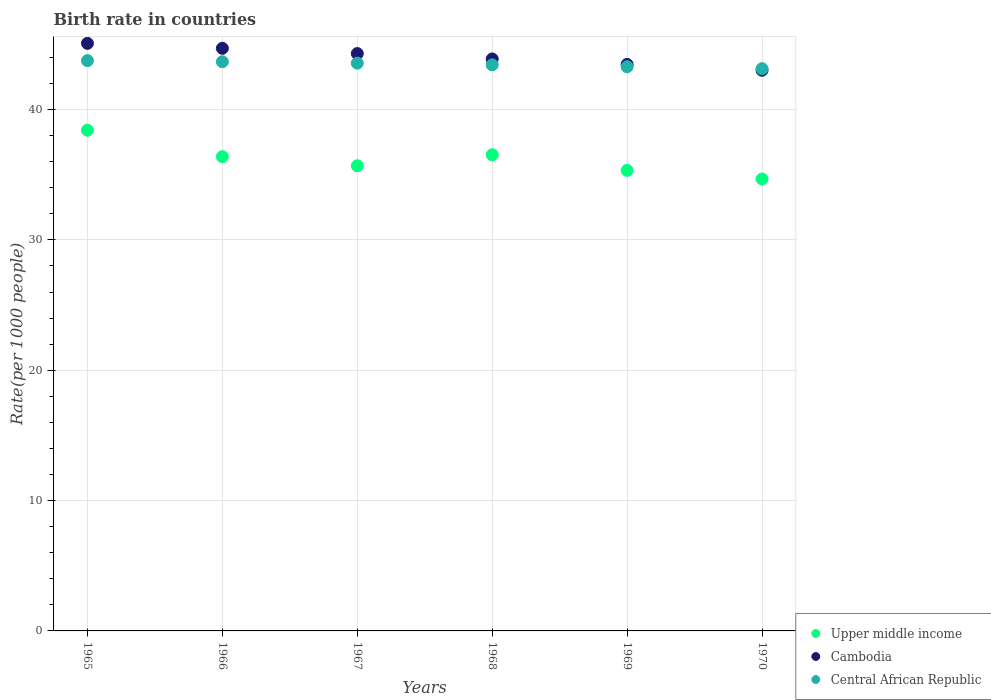What is the birth rate in Cambodia in 1965?
Give a very brief answer. 45.08. Across all years, what is the maximum birth rate in Cambodia?
Offer a very short reply. 45.08. Across all years, what is the minimum birth rate in Upper middle income?
Your answer should be compact. 34.67. In which year was the birth rate in Cambodia maximum?
Offer a very short reply. 1965. What is the total birth rate in Central African Republic in the graph?
Your answer should be compact. 260.83. What is the difference between the birth rate in Upper middle income in 1965 and that in 1970?
Your response must be concise. 3.74. What is the difference between the birth rate in Cambodia in 1970 and the birth rate in Upper middle income in 1968?
Your answer should be very brief. 6.48. What is the average birth rate in Upper middle income per year?
Provide a short and direct response. 36.17. In the year 1967, what is the difference between the birth rate in Cambodia and birth rate in Upper middle income?
Keep it short and to the point. 8.61. In how many years, is the birth rate in Upper middle income greater than 4?
Make the answer very short. 6. What is the ratio of the birth rate in Central African Republic in 1965 to that in 1967?
Give a very brief answer. 1. Is the birth rate in Upper middle income in 1966 less than that in 1969?
Your response must be concise. No. What is the difference between the highest and the second highest birth rate in Upper middle income?
Keep it short and to the point. 1.88. What is the difference between the highest and the lowest birth rate in Central African Republic?
Your response must be concise. 0.62. In how many years, is the birth rate in Upper middle income greater than the average birth rate in Upper middle income taken over all years?
Make the answer very short. 3. Is the sum of the birth rate in Upper middle income in 1967 and 1968 greater than the maximum birth rate in Central African Republic across all years?
Offer a very short reply. Yes. Is the birth rate in Upper middle income strictly less than the birth rate in Central African Republic over the years?
Your answer should be very brief. Yes. How many dotlines are there?
Provide a short and direct response. 3. Where does the legend appear in the graph?
Ensure brevity in your answer.  Bottom right. How are the legend labels stacked?
Provide a short and direct response. Vertical. What is the title of the graph?
Provide a succinct answer. Birth rate in countries. Does "Mauritius" appear as one of the legend labels in the graph?
Make the answer very short. No. What is the label or title of the X-axis?
Your answer should be very brief. Years. What is the label or title of the Y-axis?
Ensure brevity in your answer.  Rate(per 1000 people). What is the Rate(per 1000 people) of Upper middle income in 1965?
Keep it short and to the point. 38.41. What is the Rate(per 1000 people) in Cambodia in 1965?
Your response must be concise. 45.08. What is the Rate(per 1000 people) of Central African Republic in 1965?
Give a very brief answer. 43.75. What is the Rate(per 1000 people) in Upper middle income in 1966?
Your answer should be very brief. 36.39. What is the Rate(per 1000 people) of Cambodia in 1966?
Offer a very short reply. 44.7. What is the Rate(per 1000 people) in Central African Republic in 1966?
Your response must be concise. 43.67. What is the Rate(per 1000 people) in Upper middle income in 1967?
Your answer should be compact. 35.69. What is the Rate(per 1000 people) of Cambodia in 1967?
Provide a succinct answer. 44.3. What is the Rate(per 1000 people) of Central African Republic in 1967?
Ensure brevity in your answer.  43.56. What is the Rate(per 1000 people) in Upper middle income in 1968?
Make the answer very short. 36.53. What is the Rate(per 1000 people) in Cambodia in 1968?
Your answer should be very brief. 43.88. What is the Rate(per 1000 people) of Central African Republic in 1968?
Make the answer very short. 43.43. What is the Rate(per 1000 people) in Upper middle income in 1969?
Your response must be concise. 35.33. What is the Rate(per 1000 people) in Cambodia in 1969?
Ensure brevity in your answer.  43.46. What is the Rate(per 1000 people) in Central African Republic in 1969?
Ensure brevity in your answer.  43.29. What is the Rate(per 1000 people) in Upper middle income in 1970?
Provide a succinct answer. 34.67. What is the Rate(per 1000 people) in Cambodia in 1970?
Offer a very short reply. 43.02. What is the Rate(per 1000 people) of Central African Republic in 1970?
Provide a short and direct response. 43.13. Across all years, what is the maximum Rate(per 1000 people) in Upper middle income?
Keep it short and to the point. 38.41. Across all years, what is the maximum Rate(per 1000 people) in Cambodia?
Give a very brief answer. 45.08. Across all years, what is the maximum Rate(per 1000 people) in Central African Republic?
Make the answer very short. 43.75. Across all years, what is the minimum Rate(per 1000 people) of Upper middle income?
Your response must be concise. 34.67. Across all years, what is the minimum Rate(per 1000 people) of Cambodia?
Ensure brevity in your answer.  43.02. Across all years, what is the minimum Rate(per 1000 people) of Central African Republic?
Make the answer very short. 43.13. What is the total Rate(per 1000 people) of Upper middle income in the graph?
Your answer should be compact. 217.02. What is the total Rate(per 1000 people) in Cambodia in the graph?
Provide a short and direct response. 264.43. What is the total Rate(per 1000 people) of Central African Republic in the graph?
Ensure brevity in your answer.  260.83. What is the difference between the Rate(per 1000 people) in Upper middle income in 1965 and that in 1966?
Ensure brevity in your answer.  2.03. What is the difference between the Rate(per 1000 people) in Cambodia in 1965 and that in 1966?
Provide a short and direct response. 0.38. What is the difference between the Rate(per 1000 people) in Central African Republic in 1965 and that in 1966?
Provide a short and direct response. 0.08. What is the difference between the Rate(per 1000 people) in Upper middle income in 1965 and that in 1967?
Your answer should be very brief. 2.73. What is the difference between the Rate(per 1000 people) of Cambodia in 1965 and that in 1967?
Offer a terse response. 0.78. What is the difference between the Rate(per 1000 people) of Central African Republic in 1965 and that in 1967?
Offer a very short reply. 0.19. What is the difference between the Rate(per 1000 people) in Upper middle income in 1965 and that in 1968?
Offer a terse response. 1.88. What is the difference between the Rate(per 1000 people) of Cambodia in 1965 and that in 1968?
Provide a short and direct response. 1.2. What is the difference between the Rate(per 1000 people) in Central African Republic in 1965 and that in 1968?
Offer a terse response. 0.32. What is the difference between the Rate(per 1000 people) in Upper middle income in 1965 and that in 1969?
Your answer should be compact. 3.08. What is the difference between the Rate(per 1000 people) of Cambodia in 1965 and that in 1969?
Provide a succinct answer. 1.61. What is the difference between the Rate(per 1000 people) in Central African Republic in 1965 and that in 1969?
Your answer should be compact. 0.47. What is the difference between the Rate(per 1000 people) of Upper middle income in 1965 and that in 1970?
Your answer should be very brief. 3.74. What is the difference between the Rate(per 1000 people) of Cambodia in 1965 and that in 1970?
Provide a short and direct response. 2.06. What is the difference between the Rate(per 1000 people) in Central African Republic in 1965 and that in 1970?
Your answer should be compact. 0.62. What is the difference between the Rate(per 1000 people) of Upper middle income in 1966 and that in 1967?
Make the answer very short. 0.7. What is the difference between the Rate(per 1000 people) in Cambodia in 1966 and that in 1967?
Offer a very short reply. 0.4. What is the difference between the Rate(per 1000 people) in Central African Republic in 1966 and that in 1967?
Offer a terse response. 0.11. What is the difference between the Rate(per 1000 people) of Upper middle income in 1966 and that in 1968?
Ensure brevity in your answer.  -0.14. What is the difference between the Rate(per 1000 people) of Cambodia in 1966 and that in 1968?
Make the answer very short. 0.82. What is the difference between the Rate(per 1000 people) of Central African Republic in 1966 and that in 1968?
Your response must be concise. 0.24. What is the difference between the Rate(per 1000 people) of Upper middle income in 1966 and that in 1969?
Make the answer very short. 1.05. What is the difference between the Rate(per 1000 people) of Cambodia in 1966 and that in 1969?
Your response must be concise. 1.23. What is the difference between the Rate(per 1000 people) of Central African Republic in 1966 and that in 1969?
Offer a very short reply. 0.38. What is the difference between the Rate(per 1000 people) of Upper middle income in 1966 and that in 1970?
Your answer should be compact. 1.71. What is the difference between the Rate(per 1000 people) in Cambodia in 1966 and that in 1970?
Ensure brevity in your answer.  1.68. What is the difference between the Rate(per 1000 people) of Central African Republic in 1966 and that in 1970?
Provide a short and direct response. 0.53. What is the difference between the Rate(per 1000 people) of Upper middle income in 1967 and that in 1968?
Your response must be concise. -0.84. What is the difference between the Rate(per 1000 people) of Cambodia in 1967 and that in 1968?
Your response must be concise. 0.41. What is the difference between the Rate(per 1000 people) in Central African Republic in 1967 and that in 1968?
Your response must be concise. 0.13. What is the difference between the Rate(per 1000 people) in Upper middle income in 1967 and that in 1969?
Ensure brevity in your answer.  0.36. What is the difference between the Rate(per 1000 people) in Cambodia in 1967 and that in 1969?
Give a very brief answer. 0.83. What is the difference between the Rate(per 1000 people) of Central African Republic in 1967 and that in 1969?
Keep it short and to the point. 0.27. What is the difference between the Rate(per 1000 people) of Upper middle income in 1967 and that in 1970?
Your answer should be compact. 1.02. What is the difference between the Rate(per 1000 people) of Cambodia in 1967 and that in 1970?
Make the answer very short. 1.28. What is the difference between the Rate(per 1000 people) in Central African Republic in 1967 and that in 1970?
Ensure brevity in your answer.  0.42. What is the difference between the Rate(per 1000 people) in Upper middle income in 1968 and that in 1969?
Offer a terse response. 1.2. What is the difference between the Rate(per 1000 people) in Cambodia in 1968 and that in 1969?
Ensure brevity in your answer.  0.42. What is the difference between the Rate(per 1000 people) of Central African Republic in 1968 and that in 1969?
Make the answer very short. 0.14. What is the difference between the Rate(per 1000 people) in Upper middle income in 1968 and that in 1970?
Offer a very short reply. 1.86. What is the difference between the Rate(per 1000 people) in Cambodia in 1968 and that in 1970?
Offer a very short reply. 0.87. What is the difference between the Rate(per 1000 people) of Central African Republic in 1968 and that in 1970?
Offer a terse response. 0.29. What is the difference between the Rate(per 1000 people) of Upper middle income in 1969 and that in 1970?
Your answer should be very brief. 0.66. What is the difference between the Rate(per 1000 people) of Cambodia in 1969 and that in 1970?
Make the answer very short. 0.45. What is the difference between the Rate(per 1000 people) of Central African Republic in 1969 and that in 1970?
Give a very brief answer. 0.15. What is the difference between the Rate(per 1000 people) in Upper middle income in 1965 and the Rate(per 1000 people) in Cambodia in 1966?
Your answer should be very brief. -6.28. What is the difference between the Rate(per 1000 people) in Upper middle income in 1965 and the Rate(per 1000 people) in Central African Republic in 1966?
Your response must be concise. -5.25. What is the difference between the Rate(per 1000 people) in Cambodia in 1965 and the Rate(per 1000 people) in Central African Republic in 1966?
Provide a short and direct response. 1.41. What is the difference between the Rate(per 1000 people) of Upper middle income in 1965 and the Rate(per 1000 people) of Cambodia in 1967?
Keep it short and to the point. -5.88. What is the difference between the Rate(per 1000 people) of Upper middle income in 1965 and the Rate(per 1000 people) of Central African Republic in 1967?
Your answer should be compact. -5.14. What is the difference between the Rate(per 1000 people) in Cambodia in 1965 and the Rate(per 1000 people) in Central African Republic in 1967?
Make the answer very short. 1.52. What is the difference between the Rate(per 1000 people) in Upper middle income in 1965 and the Rate(per 1000 people) in Cambodia in 1968?
Offer a very short reply. -5.47. What is the difference between the Rate(per 1000 people) of Upper middle income in 1965 and the Rate(per 1000 people) of Central African Republic in 1968?
Keep it short and to the point. -5.01. What is the difference between the Rate(per 1000 people) of Cambodia in 1965 and the Rate(per 1000 people) of Central African Republic in 1968?
Give a very brief answer. 1.65. What is the difference between the Rate(per 1000 people) in Upper middle income in 1965 and the Rate(per 1000 people) in Cambodia in 1969?
Your response must be concise. -5.05. What is the difference between the Rate(per 1000 people) in Upper middle income in 1965 and the Rate(per 1000 people) in Central African Republic in 1969?
Your answer should be compact. -4.87. What is the difference between the Rate(per 1000 people) of Cambodia in 1965 and the Rate(per 1000 people) of Central African Republic in 1969?
Make the answer very short. 1.79. What is the difference between the Rate(per 1000 people) in Upper middle income in 1965 and the Rate(per 1000 people) in Cambodia in 1970?
Ensure brevity in your answer.  -4.6. What is the difference between the Rate(per 1000 people) of Upper middle income in 1965 and the Rate(per 1000 people) of Central African Republic in 1970?
Give a very brief answer. -4.72. What is the difference between the Rate(per 1000 people) in Cambodia in 1965 and the Rate(per 1000 people) in Central African Republic in 1970?
Make the answer very short. 1.95. What is the difference between the Rate(per 1000 people) of Upper middle income in 1966 and the Rate(per 1000 people) of Cambodia in 1967?
Give a very brief answer. -7.91. What is the difference between the Rate(per 1000 people) of Upper middle income in 1966 and the Rate(per 1000 people) of Central African Republic in 1967?
Your response must be concise. -7.17. What is the difference between the Rate(per 1000 people) in Cambodia in 1966 and the Rate(per 1000 people) in Central African Republic in 1967?
Keep it short and to the point. 1.14. What is the difference between the Rate(per 1000 people) of Upper middle income in 1966 and the Rate(per 1000 people) of Cambodia in 1968?
Offer a very short reply. -7.5. What is the difference between the Rate(per 1000 people) of Upper middle income in 1966 and the Rate(per 1000 people) of Central African Republic in 1968?
Give a very brief answer. -7.04. What is the difference between the Rate(per 1000 people) of Cambodia in 1966 and the Rate(per 1000 people) of Central African Republic in 1968?
Your answer should be compact. 1.27. What is the difference between the Rate(per 1000 people) in Upper middle income in 1966 and the Rate(per 1000 people) in Cambodia in 1969?
Your answer should be very brief. -7.08. What is the difference between the Rate(per 1000 people) in Upper middle income in 1966 and the Rate(per 1000 people) in Central African Republic in 1969?
Your answer should be very brief. -6.9. What is the difference between the Rate(per 1000 people) in Cambodia in 1966 and the Rate(per 1000 people) in Central African Republic in 1969?
Provide a succinct answer. 1.41. What is the difference between the Rate(per 1000 people) in Upper middle income in 1966 and the Rate(per 1000 people) in Cambodia in 1970?
Offer a terse response. -6.63. What is the difference between the Rate(per 1000 people) of Upper middle income in 1966 and the Rate(per 1000 people) of Central African Republic in 1970?
Offer a very short reply. -6.75. What is the difference between the Rate(per 1000 people) of Cambodia in 1966 and the Rate(per 1000 people) of Central African Republic in 1970?
Provide a short and direct response. 1.56. What is the difference between the Rate(per 1000 people) in Upper middle income in 1967 and the Rate(per 1000 people) in Cambodia in 1968?
Make the answer very short. -8.19. What is the difference between the Rate(per 1000 people) in Upper middle income in 1967 and the Rate(per 1000 people) in Central African Republic in 1968?
Provide a short and direct response. -7.74. What is the difference between the Rate(per 1000 people) of Cambodia in 1967 and the Rate(per 1000 people) of Central African Republic in 1968?
Provide a succinct answer. 0.87. What is the difference between the Rate(per 1000 people) of Upper middle income in 1967 and the Rate(per 1000 people) of Cambodia in 1969?
Your answer should be compact. -7.78. What is the difference between the Rate(per 1000 people) of Upper middle income in 1967 and the Rate(per 1000 people) of Central African Republic in 1969?
Your response must be concise. -7.6. What is the difference between the Rate(per 1000 people) of Upper middle income in 1967 and the Rate(per 1000 people) of Cambodia in 1970?
Your answer should be compact. -7.33. What is the difference between the Rate(per 1000 people) of Upper middle income in 1967 and the Rate(per 1000 people) of Central African Republic in 1970?
Provide a short and direct response. -7.45. What is the difference between the Rate(per 1000 people) in Cambodia in 1967 and the Rate(per 1000 people) in Central African Republic in 1970?
Keep it short and to the point. 1.16. What is the difference between the Rate(per 1000 people) in Upper middle income in 1968 and the Rate(per 1000 people) in Cambodia in 1969?
Provide a short and direct response. -6.93. What is the difference between the Rate(per 1000 people) in Upper middle income in 1968 and the Rate(per 1000 people) in Central African Republic in 1969?
Make the answer very short. -6.75. What is the difference between the Rate(per 1000 people) in Cambodia in 1968 and the Rate(per 1000 people) in Central African Republic in 1969?
Provide a succinct answer. 0.6. What is the difference between the Rate(per 1000 people) of Upper middle income in 1968 and the Rate(per 1000 people) of Cambodia in 1970?
Keep it short and to the point. -6.48. What is the difference between the Rate(per 1000 people) of Upper middle income in 1968 and the Rate(per 1000 people) of Central African Republic in 1970?
Your answer should be very brief. -6.6. What is the difference between the Rate(per 1000 people) of Cambodia in 1968 and the Rate(per 1000 people) of Central African Republic in 1970?
Keep it short and to the point. 0.75. What is the difference between the Rate(per 1000 people) in Upper middle income in 1969 and the Rate(per 1000 people) in Cambodia in 1970?
Provide a short and direct response. -7.68. What is the difference between the Rate(per 1000 people) in Upper middle income in 1969 and the Rate(per 1000 people) in Central African Republic in 1970?
Provide a succinct answer. -7.8. What is the difference between the Rate(per 1000 people) in Cambodia in 1969 and the Rate(per 1000 people) in Central African Republic in 1970?
Give a very brief answer. 0.33. What is the average Rate(per 1000 people) in Upper middle income per year?
Ensure brevity in your answer.  36.17. What is the average Rate(per 1000 people) in Cambodia per year?
Your answer should be very brief. 44.07. What is the average Rate(per 1000 people) of Central African Republic per year?
Give a very brief answer. 43.47. In the year 1965, what is the difference between the Rate(per 1000 people) of Upper middle income and Rate(per 1000 people) of Cambodia?
Provide a succinct answer. -6.67. In the year 1965, what is the difference between the Rate(per 1000 people) of Upper middle income and Rate(per 1000 people) of Central African Republic?
Provide a succinct answer. -5.34. In the year 1965, what is the difference between the Rate(per 1000 people) of Cambodia and Rate(per 1000 people) of Central African Republic?
Your answer should be compact. 1.33. In the year 1966, what is the difference between the Rate(per 1000 people) of Upper middle income and Rate(per 1000 people) of Cambodia?
Your answer should be compact. -8.31. In the year 1966, what is the difference between the Rate(per 1000 people) in Upper middle income and Rate(per 1000 people) in Central African Republic?
Give a very brief answer. -7.28. In the year 1966, what is the difference between the Rate(per 1000 people) in Cambodia and Rate(per 1000 people) in Central African Republic?
Offer a very short reply. 1.03. In the year 1967, what is the difference between the Rate(per 1000 people) of Upper middle income and Rate(per 1000 people) of Cambodia?
Your answer should be compact. -8.61. In the year 1967, what is the difference between the Rate(per 1000 people) of Upper middle income and Rate(per 1000 people) of Central African Republic?
Provide a short and direct response. -7.87. In the year 1967, what is the difference between the Rate(per 1000 people) of Cambodia and Rate(per 1000 people) of Central African Republic?
Offer a very short reply. 0.74. In the year 1968, what is the difference between the Rate(per 1000 people) in Upper middle income and Rate(per 1000 people) in Cambodia?
Make the answer very short. -7.35. In the year 1968, what is the difference between the Rate(per 1000 people) of Upper middle income and Rate(per 1000 people) of Central African Republic?
Ensure brevity in your answer.  -6.9. In the year 1968, what is the difference between the Rate(per 1000 people) of Cambodia and Rate(per 1000 people) of Central African Republic?
Your answer should be compact. 0.45. In the year 1969, what is the difference between the Rate(per 1000 people) in Upper middle income and Rate(per 1000 people) in Cambodia?
Make the answer very short. -8.13. In the year 1969, what is the difference between the Rate(per 1000 people) in Upper middle income and Rate(per 1000 people) in Central African Republic?
Make the answer very short. -7.95. In the year 1969, what is the difference between the Rate(per 1000 people) of Cambodia and Rate(per 1000 people) of Central African Republic?
Provide a short and direct response. 0.18. In the year 1970, what is the difference between the Rate(per 1000 people) in Upper middle income and Rate(per 1000 people) in Cambodia?
Your response must be concise. -8.34. In the year 1970, what is the difference between the Rate(per 1000 people) of Upper middle income and Rate(per 1000 people) of Central African Republic?
Give a very brief answer. -8.46. In the year 1970, what is the difference between the Rate(per 1000 people) in Cambodia and Rate(per 1000 people) in Central African Republic?
Keep it short and to the point. -0.12. What is the ratio of the Rate(per 1000 people) in Upper middle income in 1965 to that in 1966?
Give a very brief answer. 1.06. What is the ratio of the Rate(per 1000 people) in Cambodia in 1965 to that in 1966?
Provide a succinct answer. 1.01. What is the ratio of the Rate(per 1000 people) in Central African Republic in 1965 to that in 1966?
Give a very brief answer. 1. What is the ratio of the Rate(per 1000 people) of Upper middle income in 1965 to that in 1967?
Make the answer very short. 1.08. What is the ratio of the Rate(per 1000 people) of Cambodia in 1965 to that in 1967?
Ensure brevity in your answer.  1.02. What is the ratio of the Rate(per 1000 people) of Central African Republic in 1965 to that in 1967?
Offer a terse response. 1. What is the ratio of the Rate(per 1000 people) in Upper middle income in 1965 to that in 1968?
Make the answer very short. 1.05. What is the ratio of the Rate(per 1000 people) in Cambodia in 1965 to that in 1968?
Your answer should be compact. 1.03. What is the ratio of the Rate(per 1000 people) in Central African Republic in 1965 to that in 1968?
Offer a very short reply. 1.01. What is the ratio of the Rate(per 1000 people) of Upper middle income in 1965 to that in 1969?
Provide a short and direct response. 1.09. What is the ratio of the Rate(per 1000 people) in Cambodia in 1965 to that in 1969?
Offer a very short reply. 1.04. What is the ratio of the Rate(per 1000 people) in Central African Republic in 1965 to that in 1969?
Make the answer very short. 1.01. What is the ratio of the Rate(per 1000 people) in Upper middle income in 1965 to that in 1970?
Give a very brief answer. 1.11. What is the ratio of the Rate(per 1000 people) of Cambodia in 1965 to that in 1970?
Keep it short and to the point. 1.05. What is the ratio of the Rate(per 1000 people) of Central African Republic in 1965 to that in 1970?
Ensure brevity in your answer.  1.01. What is the ratio of the Rate(per 1000 people) in Upper middle income in 1966 to that in 1967?
Your answer should be very brief. 1.02. What is the ratio of the Rate(per 1000 people) of Cambodia in 1966 to that in 1967?
Keep it short and to the point. 1.01. What is the ratio of the Rate(per 1000 people) of Central African Republic in 1966 to that in 1967?
Provide a short and direct response. 1. What is the ratio of the Rate(per 1000 people) of Cambodia in 1966 to that in 1968?
Give a very brief answer. 1.02. What is the ratio of the Rate(per 1000 people) in Upper middle income in 1966 to that in 1969?
Make the answer very short. 1.03. What is the ratio of the Rate(per 1000 people) of Cambodia in 1966 to that in 1969?
Offer a terse response. 1.03. What is the ratio of the Rate(per 1000 people) in Central African Republic in 1966 to that in 1969?
Offer a very short reply. 1.01. What is the ratio of the Rate(per 1000 people) in Upper middle income in 1966 to that in 1970?
Provide a succinct answer. 1.05. What is the ratio of the Rate(per 1000 people) in Cambodia in 1966 to that in 1970?
Keep it short and to the point. 1.04. What is the ratio of the Rate(per 1000 people) in Central African Republic in 1966 to that in 1970?
Your answer should be very brief. 1.01. What is the ratio of the Rate(per 1000 people) of Upper middle income in 1967 to that in 1968?
Your answer should be very brief. 0.98. What is the ratio of the Rate(per 1000 people) in Cambodia in 1967 to that in 1968?
Your answer should be very brief. 1.01. What is the ratio of the Rate(per 1000 people) of Central African Republic in 1967 to that in 1968?
Keep it short and to the point. 1. What is the ratio of the Rate(per 1000 people) of Upper middle income in 1967 to that in 1969?
Your response must be concise. 1.01. What is the ratio of the Rate(per 1000 people) of Cambodia in 1967 to that in 1969?
Your response must be concise. 1.02. What is the ratio of the Rate(per 1000 people) of Central African Republic in 1967 to that in 1969?
Make the answer very short. 1.01. What is the ratio of the Rate(per 1000 people) of Upper middle income in 1967 to that in 1970?
Your response must be concise. 1.03. What is the ratio of the Rate(per 1000 people) in Cambodia in 1967 to that in 1970?
Give a very brief answer. 1.03. What is the ratio of the Rate(per 1000 people) in Central African Republic in 1967 to that in 1970?
Offer a terse response. 1.01. What is the ratio of the Rate(per 1000 people) of Upper middle income in 1968 to that in 1969?
Ensure brevity in your answer.  1.03. What is the ratio of the Rate(per 1000 people) of Cambodia in 1968 to that in 1969?
Your answer should be very brief. 1.01. What is the ratio of the Rate(per 1000 people) of Central African Republic in 1968 to that in 1969?
Give a very brief answer. 1. What is the ratio of the Rate(per 1000 people) in Upper middle income in 1968 to that in 1970?
Ensure brevity in your answer.  1.05. What is the ratio of the Rate(per 1000 people) in Cambodia in 1968 to that in 1970?
Your answer should be very brief. 1.02. What is the ratio of the Rate(per 1000 people) in Central African Republic in 1968 to that in 1970?
Ensure brevity in your answer.  1.01. What is the ratio of the Rate(per 1000 people) of Cambodia in 1969 to that in 1970?
Your answer should be very brief. 1.01. What is the difference between the highest and the second highest Rate(per 1000 people) of Upper middle income?
Ensure brevity in your answer.  1.88. What is the difference between the highest and the second highest Rate(per 1000 people) of Cambodia?
Provide a succinct answer. 0.38. What is the difference between the highest and the second highest Rate(per 1000 people) in Central African Republic?
Make the answer very short. 0.08. What is the difference between the highest and the lowest Rate(per 1000 people) of Upper middle income?
Provide a short and direct response. 3.74. What is the difference between the highest and the lowest Rate(per 1000 people) in Cambodia?
Make the answer very short. 2.06. What is the difference between the highest and the lowest Rate(per 1000 people) of Central African Republic?
Give a very brief answer. 0.62. 